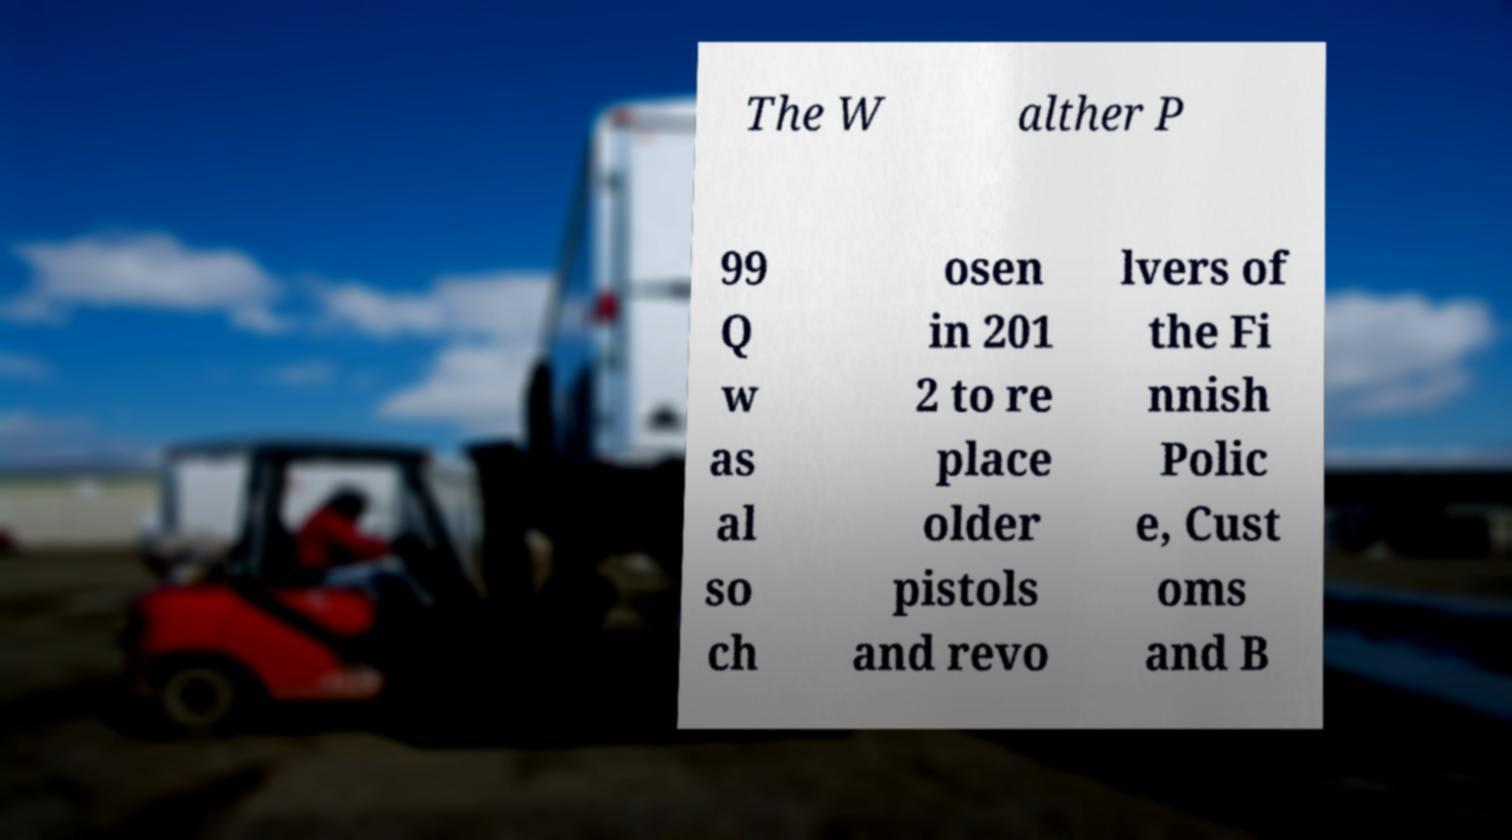What messages or text are displayed in this image? I need them in a readable, typed format. The W alther P 99 Q w as al so ch osen in 201 2 to re place older pistols and revo lvers of the Fi nnish Polic e, Cust oms and B 